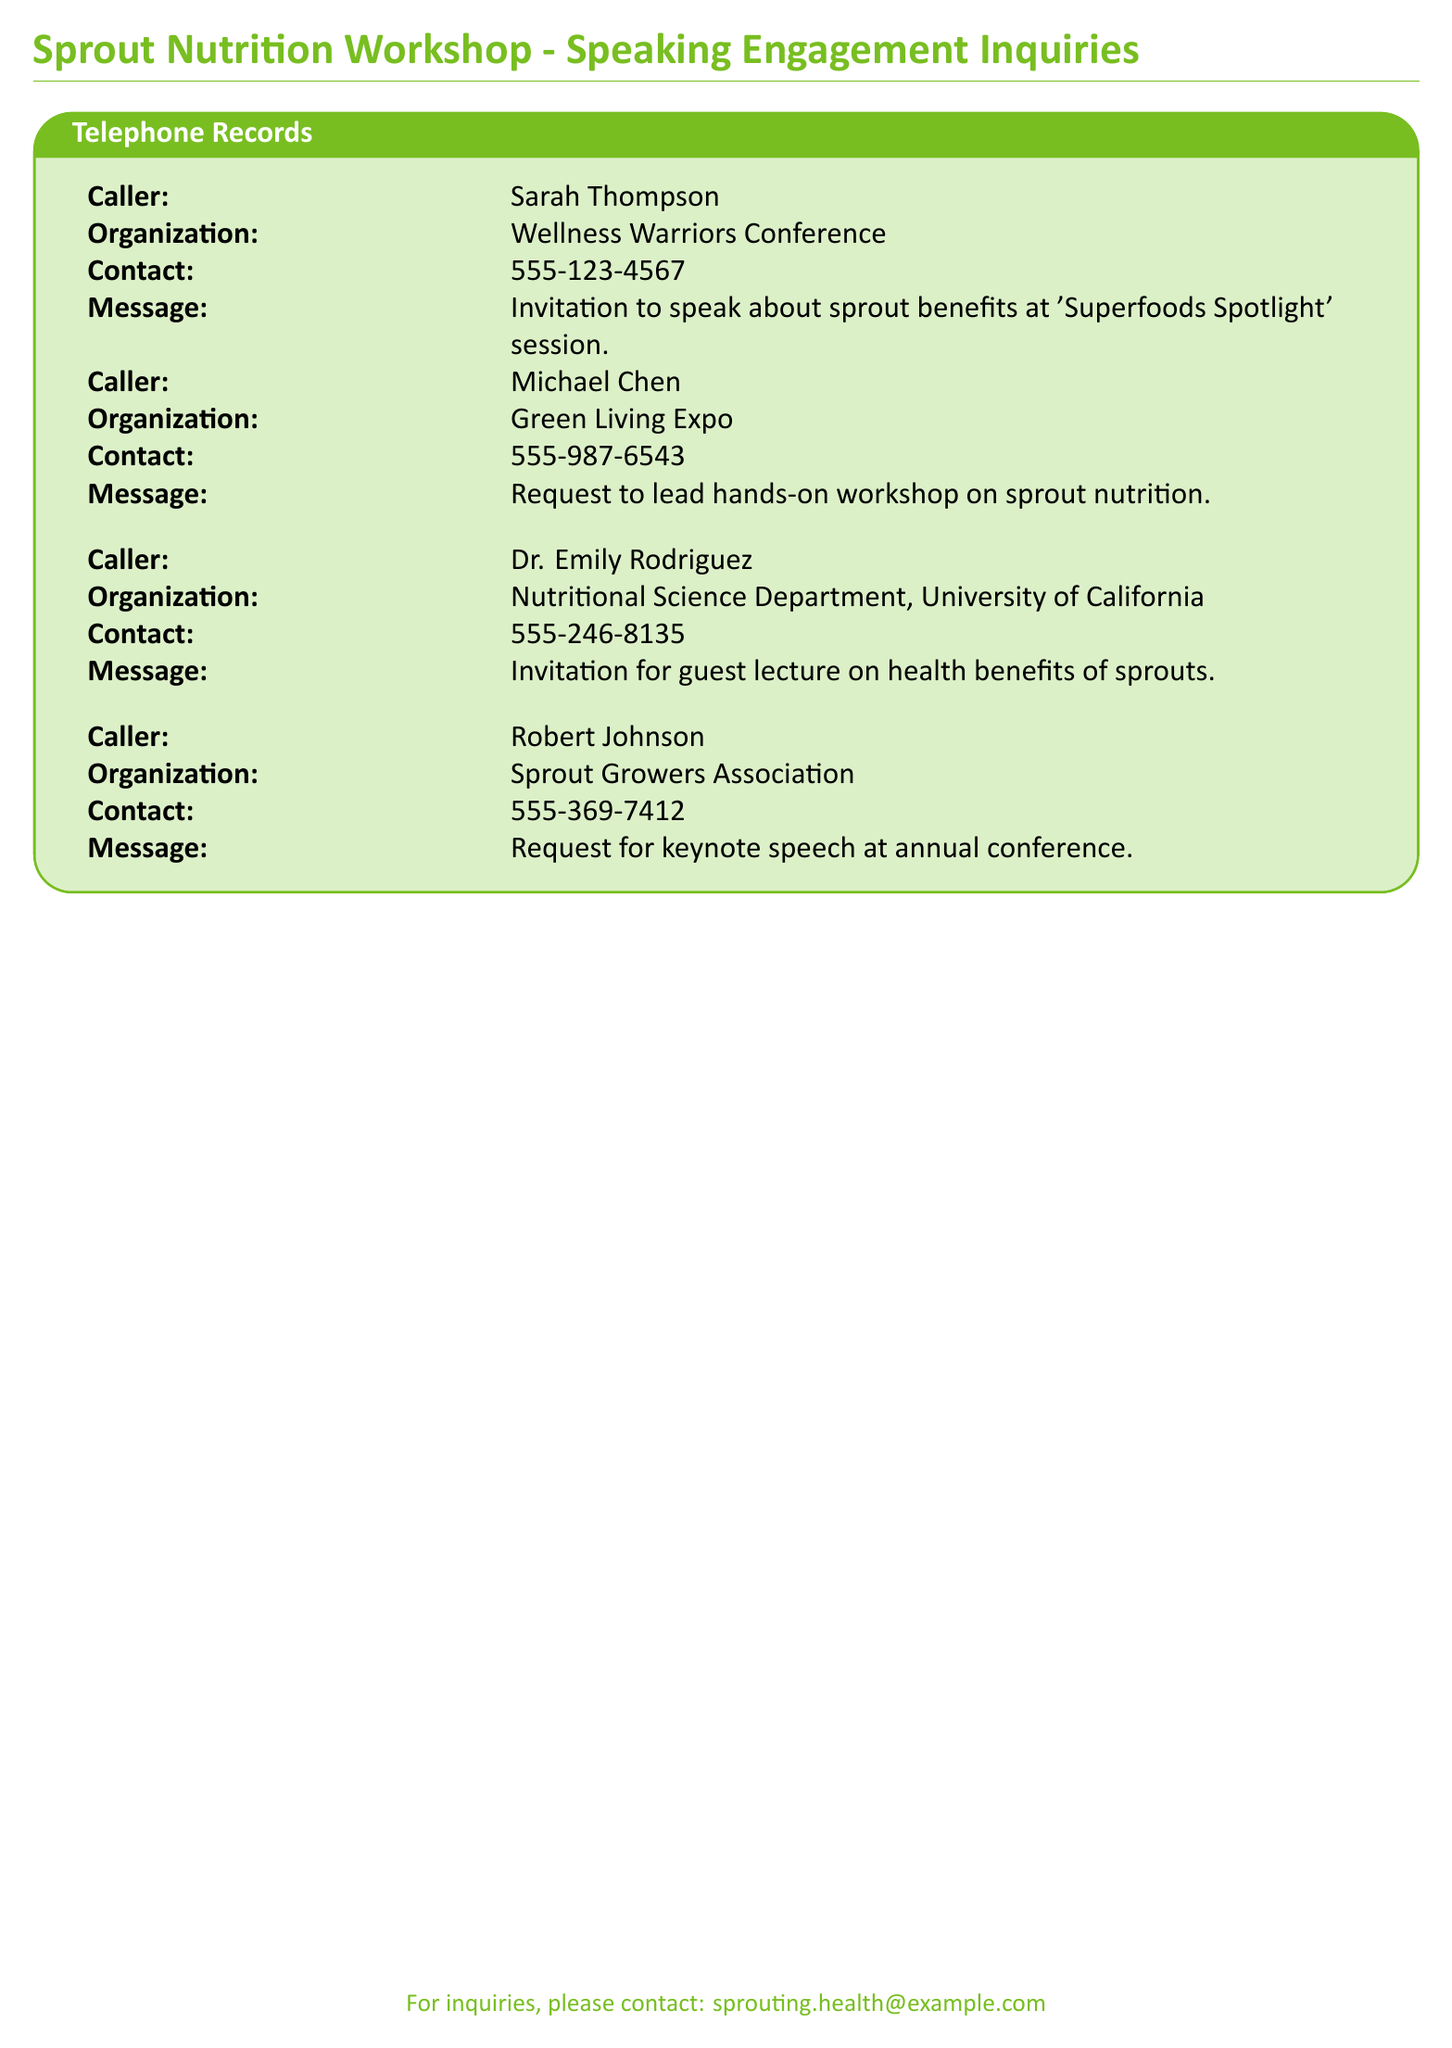What is the name of the first caller? The first caller listed in the document is Sarah Thompson.
Answer: Sarah Thompson Which organization is hosting the 'Superfoods Spotlight' session? The organization mentioned for the session is Wellness Warriors Conference.
Answer: Wellness Warriors Conference What is Dr. Emily Rodriguez's title? Dr. Emily Rodriguez is associated with the Nutritional Science Department.
Answer: Nutritional Science Department How many callers are requesting a speaking engagement? There are four callers listed in the document.
Answer: Four Which caller requested a hands-on workshop? The caller who requested a hands-on workshop is Michael Chen.
Answer: Michael Chen What is the contact number for Robert Johnson? The contact number provided by Robert Johnson is 555-369-7412.
Answer: 555-369-7412 What type of speech is Robert Johnson requesting? Robert Johnson is requesting a keynote speech at the annual conference.
Answer: Keynote speech What was the purpose of Dr. Emily Rodriguez's call? Dr. Emily Rodriguez's call was for an invitation for a guest lecture.
Answer: Invitation for guest lecture 